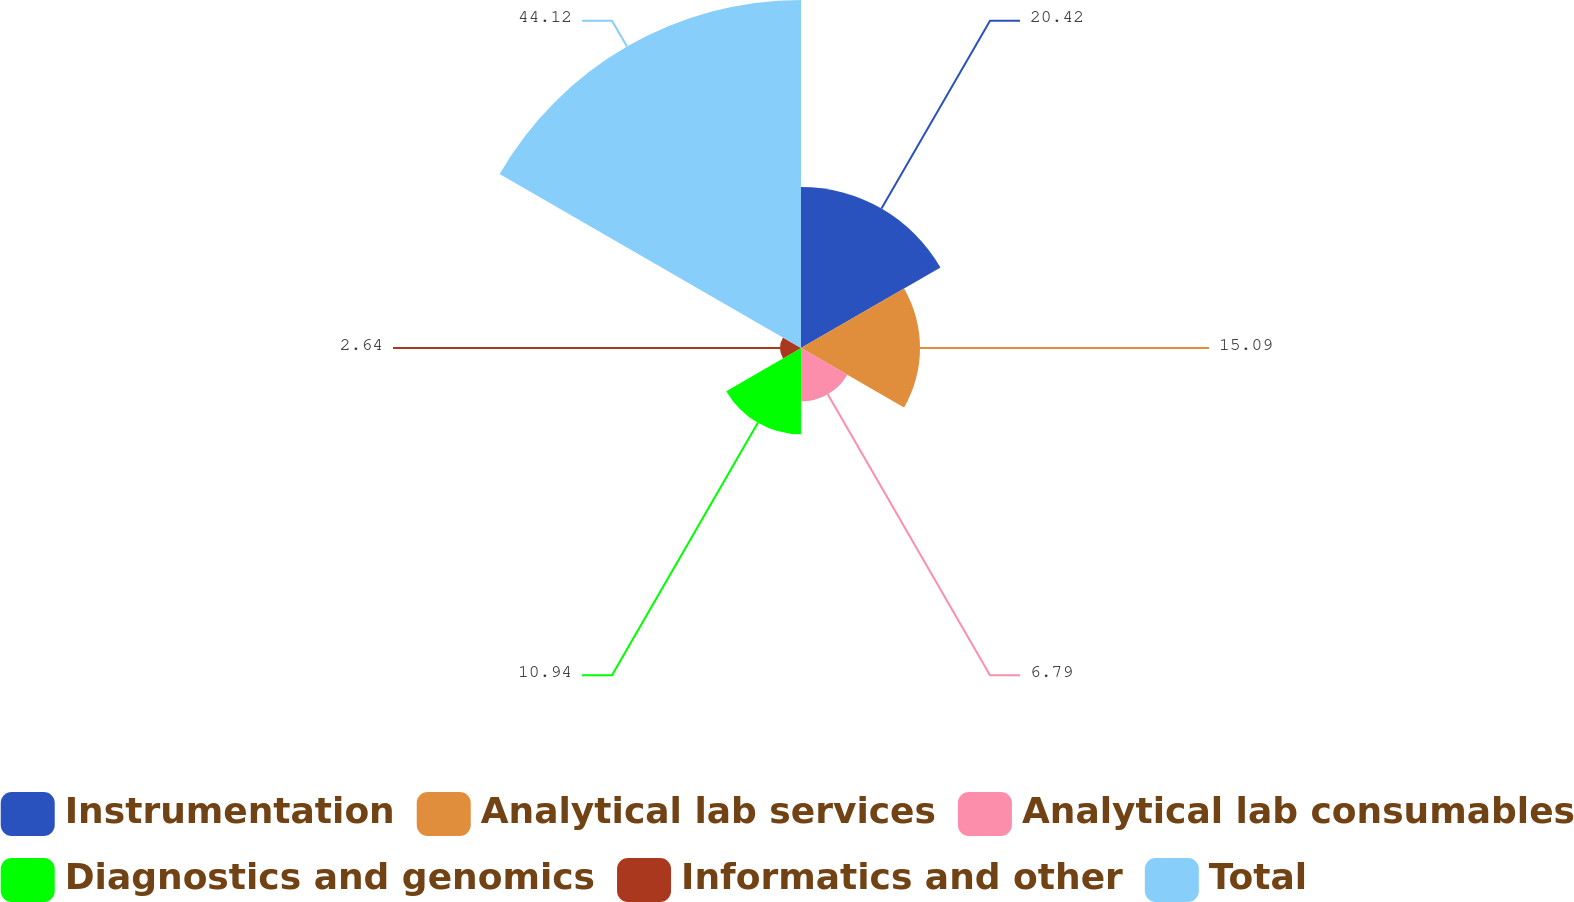Convert chart. <chart><loc_0><loc_0><loc_500><loc_500><pie_chart><fcel>Instrumentation<fcel>Analytical lab services<fcel>Analytical lab consumables<fcel>Diagnostics and genomics<fcel>Informatics and other<fcel>Total<nl><fcel>20.42%<fcel>15.09%<fcel>6.79%<fcel>10.94%<fcel>2.64%<fcel>44.13%<nl></chart> 